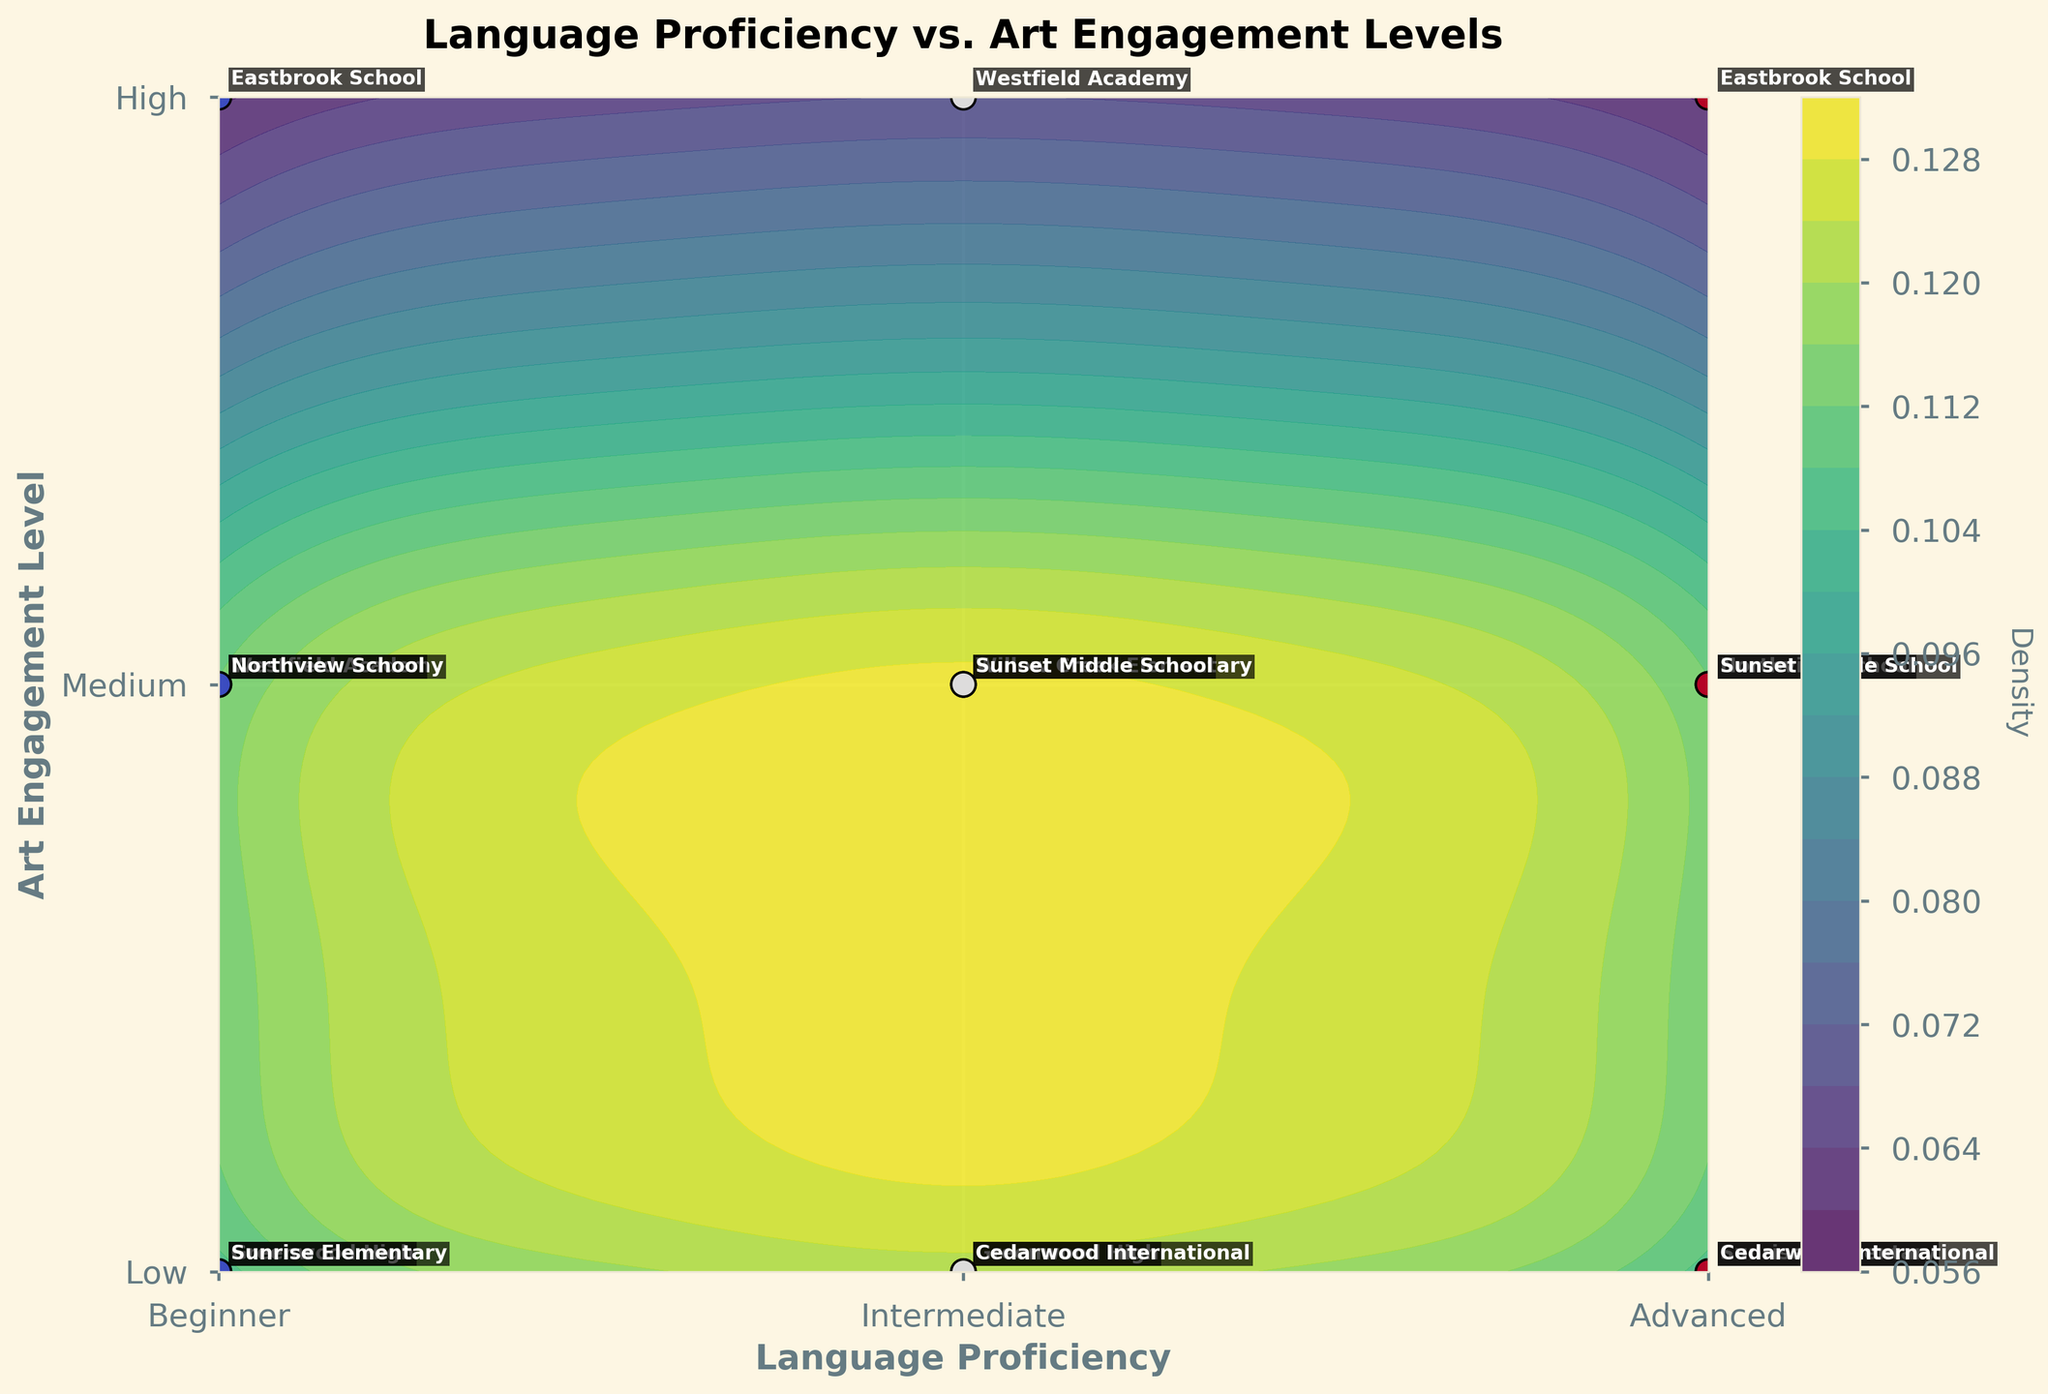What is the title of the figure? The title of a figure is usually displayed prominently at the top, summarizing what the chart is about. Here, it says "Language Proficiency vs. Art Engagement Levels."
Answer: Language Proficiency vs. Art Engagement Levels What are the labels on the x-axis and y-axis? X-axis labels describe the horizontal dimension of the plot, and Y-axis labels describe the vertical dimension. Here, the x-axis is labeled "Language Proficiency," and the y-axis is labeled "Art Engagement Level."
Answer: Language Proficiency; Art Engagement Level Which school has the highest art engagement level for advanced language proficiency? We need to look at the points labeled as "Advanced" on the x-axis and find the one that reaches the highest position on the y-axis, which represents "High" engagement. Here, the label is "Eastbrook School."
Answer: Eastbrook School How many schools fall under beginner-level language proficiency and medium art engagement? Identify the points that fall under the "Beginner" label on the x-axis and "Medium" on the y-axis. Here, there are two such points: Westfield Academy and Northview School.
Answer: 2 Which group or category has the densest data points, according to the contour colors? Identify the darkest or most intense region of the contour plot which indicates the highest density. Here, it's around Intermediate language proficiency and Low to Medium art engagement levels.
Answer: Intermediate, Low-Medium What is the proportion of schools with high art engagement compared to the total number of schools? First, count the total number of schools, which is 15. Then, count the number of schools with "High" art engagement, which is 5. The proportion is 5 out of 15, which simplifies to 1/3.
Answer: 1/3 Compare the number of schools with low art engagement across different proficiency levels. Count the number of schools in each proficiency level that has low art engagement: Beginner has 2, Intermediate has 2, and Advanced has 2. They are all equal.
Answer: Same for all Does Eastbrook School have higher art engagement than Cedarwood International at the same proficiency level? Eastbrook and Cedarwood International both have data points at "Advanced" proficiency. Comparing their y-axis values, Eastbrook is at High, and Cedarwood is at Low.
Answer: Yes Which school is located at Intermediate language proficiency and High art engagement? Find the point on the plot where the x-axis is Intermediate, and the y-axis is High, then look at the labeled annotation. This is Westfield Academy.
Answer: Westfield Academy Are there more schools at beginner-level or advanced-level language proficiency with high art engagement? Count the number of schools at "Beginner" and "Advanced" proficiency levels on the x-axis that also fall under the "High" engagement on the y-axis. Both levels have one school each: Beginner (Eastbrook School) and Advanced (Eastbrook School).
Answer: Same number 